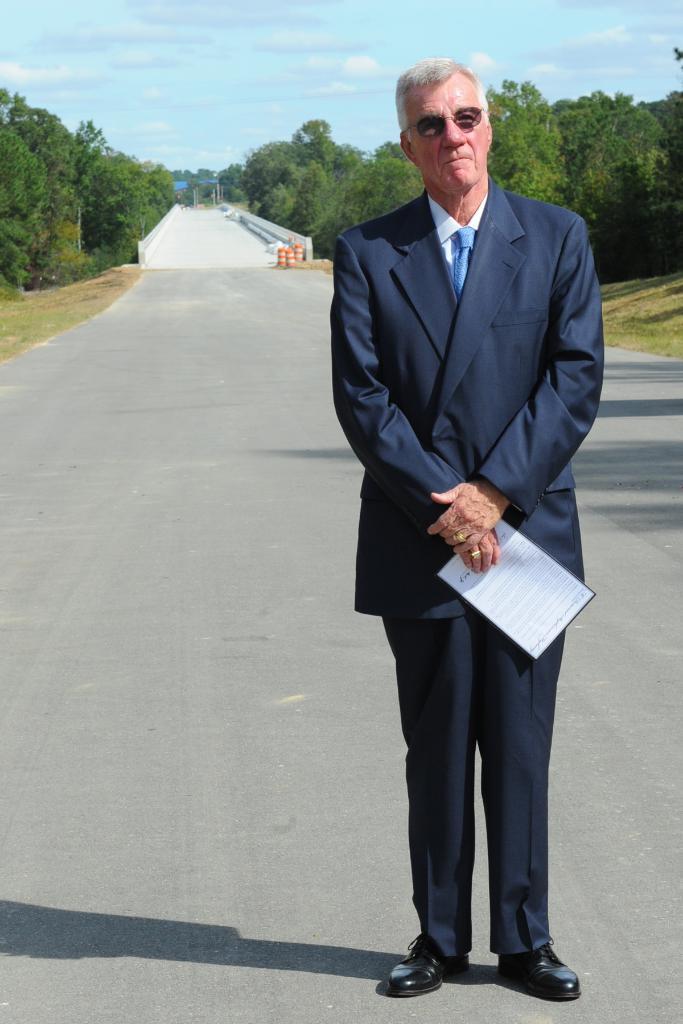How would you summarize this image in a sentence or two? In the foreground, I can see a person is standing on the road and is holding an object in hand. In the background, I can see grass, trees, bridge, light poles, water and the sky. This picture might be taken in a day. 